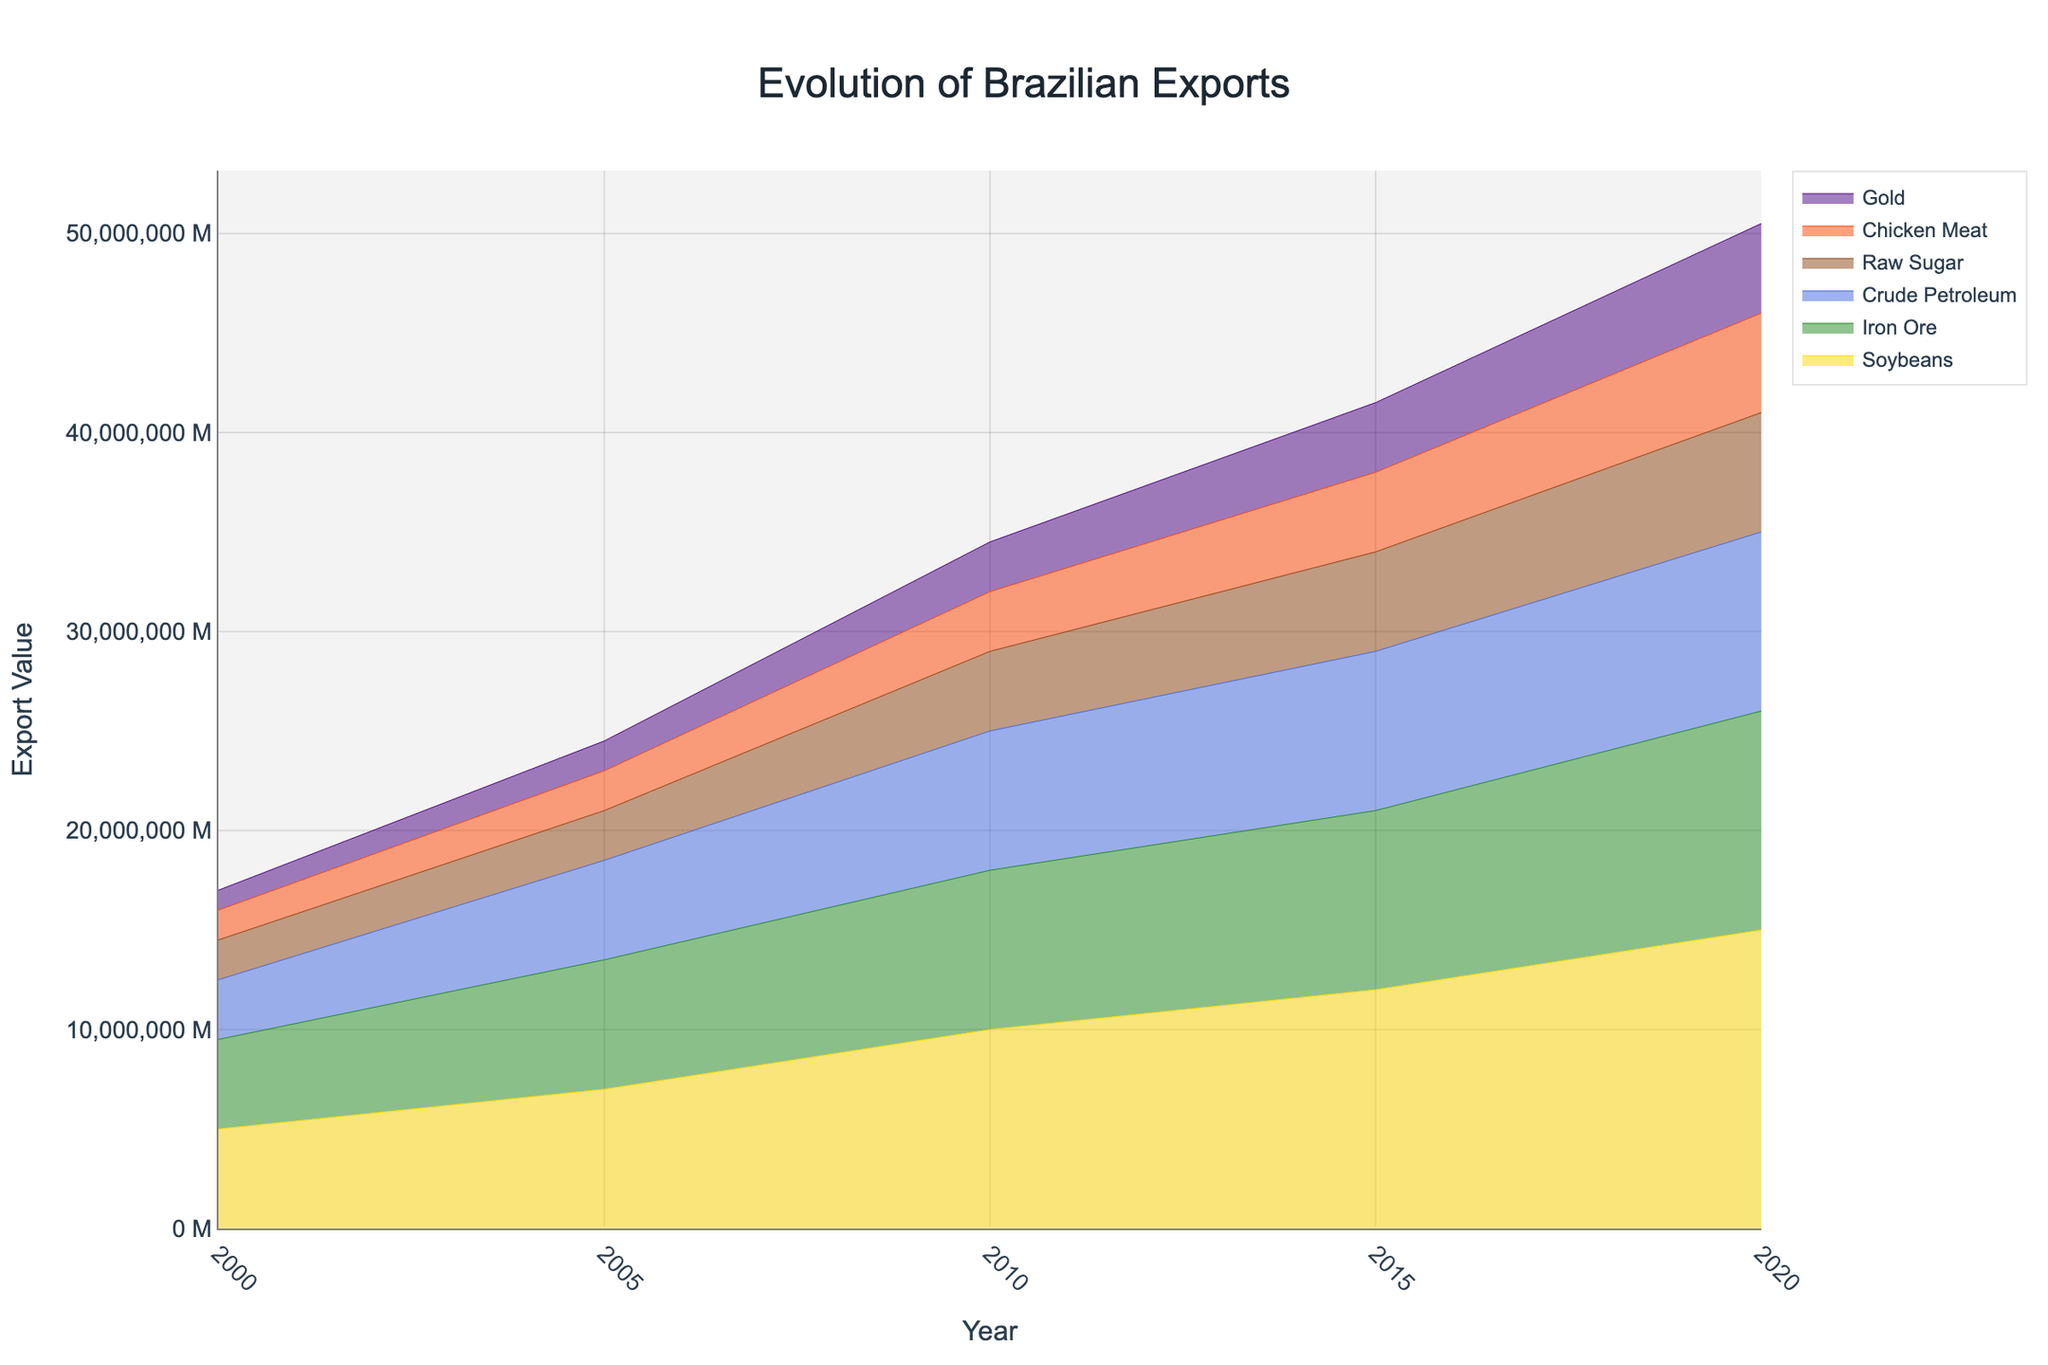What is the title of the figure? The title is displayed prominently at the top of the figure. It is usually written in a larger and bolder font compared to other text on the plot.
Answer: Evolution of Brazilian Exports Which commodity had the highest export value in 2020? To find this, observe the stack layers at the point corresponding to the year 2020 and identify the highest value. The wider the layer at 2020, the higher the commodity's export value is.
Answer: Soybeans How did the export value of Iron Ore change from 2000 to 2020? Look at the stream layer/color representing Iron Ore at the years 2000 and 2020. Note the heights of these layers and compare.
Answer: Increased What was the approximate export value of Chicken Meat in 2005? Identify the stream layer for Chicken Meat and trace it to the 2005 mark on the x-axis. Note down the corresponding y-axis value.
Answer: Approximately 2 million Did the export value of Raw Sugar increase continuously over the years from 2000 to 2020? Observe the stream layer for Raw Sugar and see if there is an upward trend with no decline at any point between 2000 and 2020.
Answer: No Which commodity showed the most significant increase in export value from 2000 to 2020? Compare all commodities' layer heights at 2000 and 2020. Identify the commodity with the largest difference in height.
Answer: Soybeans What is the total export value for the year 2015? Sum the y-values of all the commodities' layers at the 2015 point.
Answer: Soybeans (12M) + Iron Ore (9M) + Crude Petroleum (8M) + Raw Sugar (5M) + Chicken Meat (4M) + Gold (3.5M) = 41.5M How does the export value of Gold in 2020 compare to that of 2010? Trace the stream layer for Gold to the points 2010 and 2020 and compare the respective heights.
Answer: Higher in 2020 Which year experienced the highest total combined export value? Sum the heights of all the layers for each year and identify the year with the highest sum.
Answer: 2020 What trend do you observe for Chicken Meat exports from 2000 to 2020? Follow the stream layer for Chicken Meat from left (2000) to right (2020) and note the overall direction of the layer's height.
Answer: Increasing Trend 